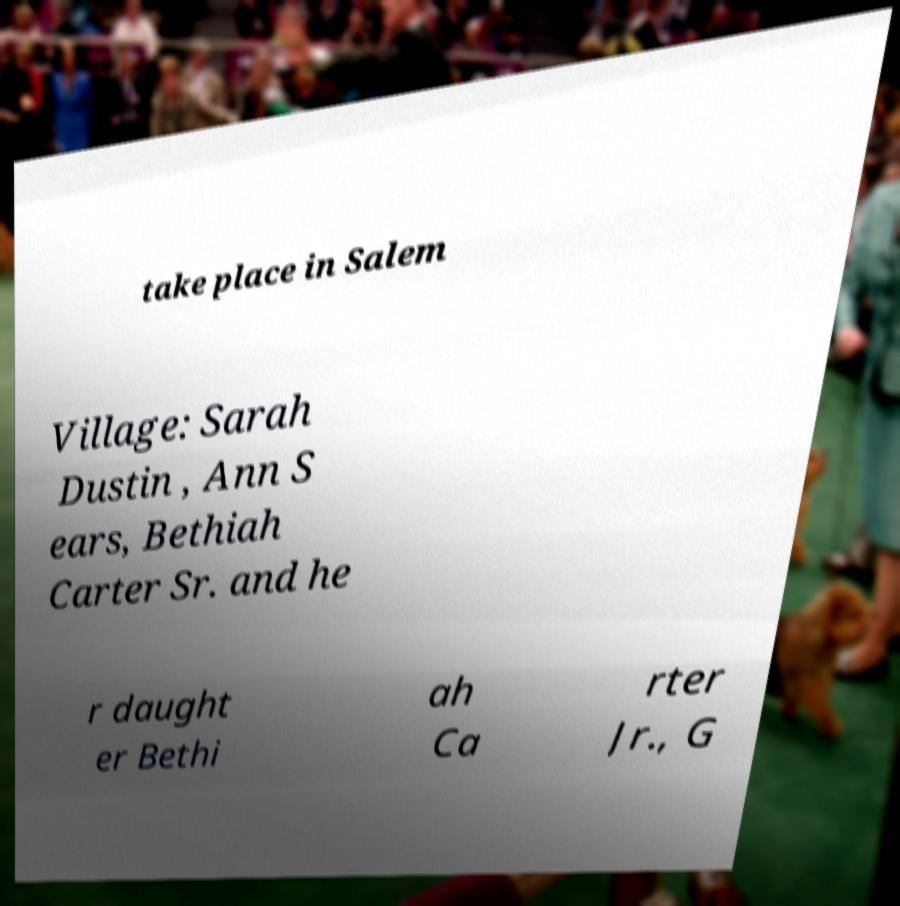What messages or text are displayed in this image? I need them in a readable, typed format. take place in Salem Village: Sarah Dustin , Ann S ears, Bethiah Carter Sr. and he r daught er Bethi ah Ca rter Jr., G 